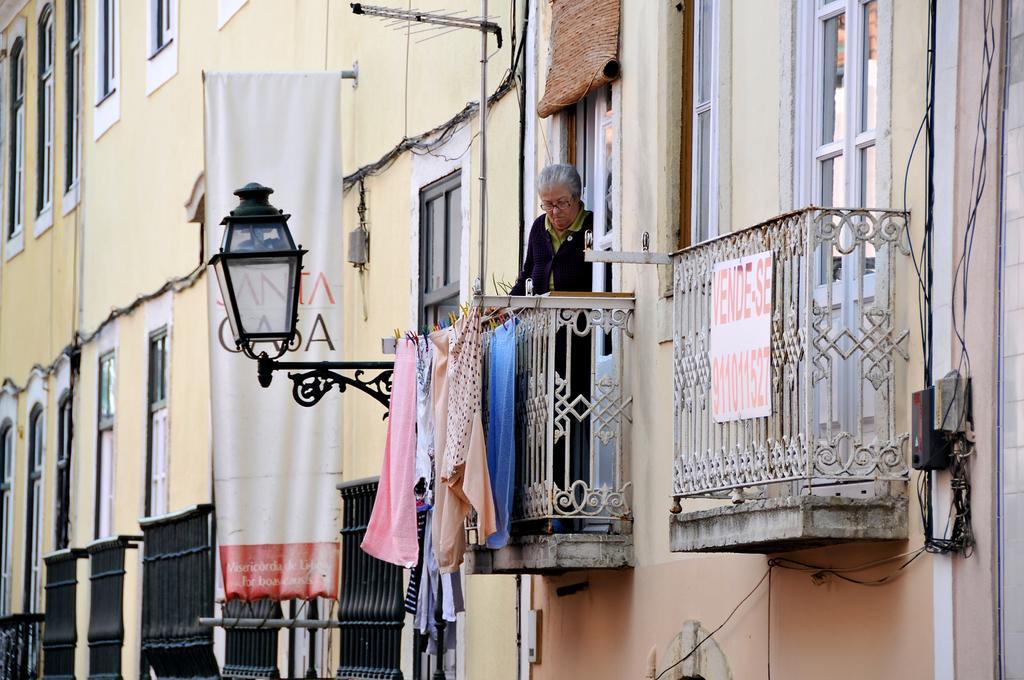How would you summarize this image in a sentence or two? In this image there are windows, clothes, a person, grilles, board, banner, lamp, boxes, cables and objects. Something is written on the board and banner. Board is on the grille. 